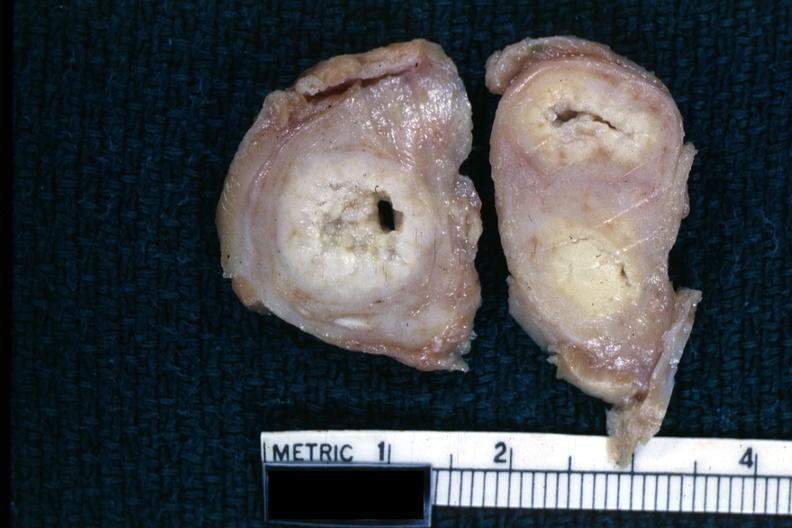s female reproductive present?
Answer the question using a single word or phrase. Yes 